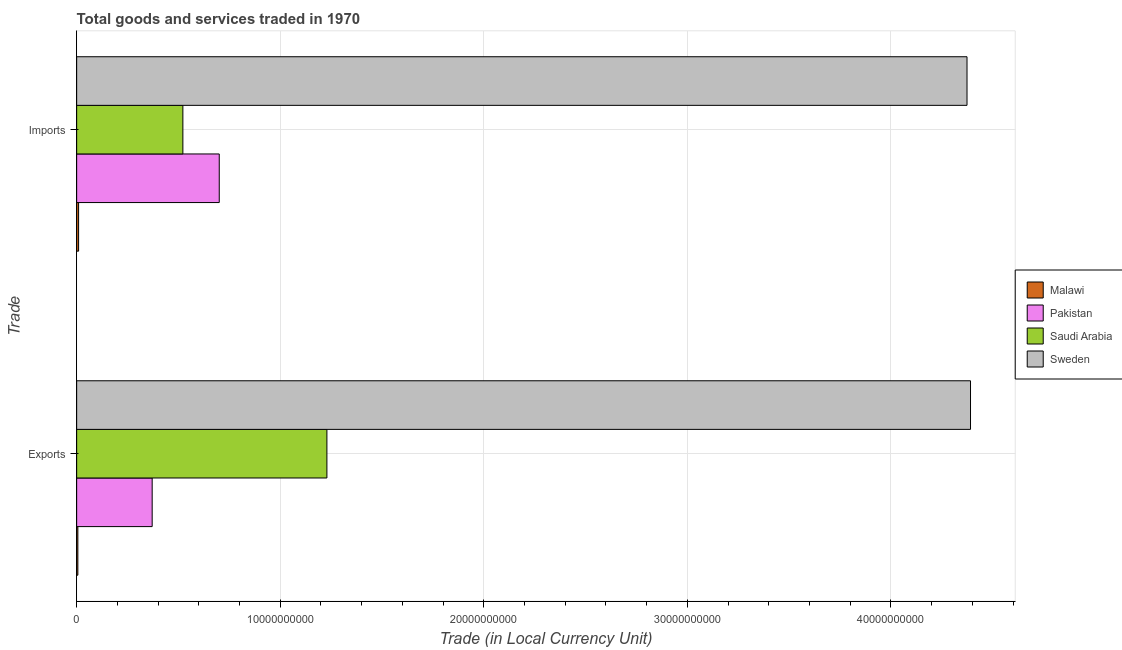How many different coloured bars are there?
Keep it short and to the point. 4. How many bars are there on the 2nd tick from the bottom?
Keep it short and to the point. 4. What is the label of the 2nd group of bars from the top?
Ensure brevity in your answer.  Exports. What is the imports of goods and services in Malawi?
Your answer should be very brief. 9.48e+07. Across all countries, what is the maximum export of goods and services?
Your answer should be compact. 4.39e+1. Across all countries, what is the minimum export of goods and services?
Your answer should be very brief. 5.87e+07. In which country was the export of goods and services maximum?
Make the answer very short. Sweden. In which country was the imports of goods and services minimum?
Your answer should be very brief. Malawi. What is the total imports of goods and services in the graph?
Provide a short and direct response. 5.61e+1. What is the difference between the export of goods and services in Pakistan and that in Sweden?
Your response must be concise. -4.02e+1. What is the difference between the imports of goods and services in Saudi Arabia and the export of goods and services in Malawi?
Provide a succinct answer. 5.16e+09. What is the average imports of goods and services per country?
Offer a very short reply. 1.40e+1. What is the difference between the imports of goods and services and export of goods and services in Pakistan?
Provide a short and direct response. 3.30e+09. In how many countries, is the export of goods and services greater than 2000000000 LCU?
Provide a succinct answer. 3. What is the ratio of the imports of goods and services in Pakistan to that in Malawi?
Offer a very short reply. 73.89. In how many countries, is the imports of goods and services greater than the average imports of goods and services taken over all countries?
Ensure brevity in your answer.  1. What does the 3rd bar from the bottom in Imports represents?
Keep it short and to the point. Saudi Arabia. How many bars are there?
Ensure brevity in your answer.  8. Are the values on the major ticks of X-axis written in scientific E-notation?
Make the answer very short. No. Does the graph contain any zero values?
Make the answer very short. No. Does the graph contain grids?
Provide a succinct answer. Yes. What is the title of the graph?
Give a very brief answer. Total goods and services traded in 1970. Does "Qatar" appear as one of the legend labels in the graph?
Your response must be concise. No. What is the label or title of the X-axis?
Your response must be concise. Trade (in Local Currency Unit). What is the label or title of the Y-axis?
Ensure brevity in your answer.  Trade. What is the Trade (in Local Currency Unit) of Malawi in Exports?
Provide a succinct answer. 5.87e+07. What is the Trade (in Local Currency Unit) in Pakistan in Exports?
Ensure brevity in your answer.  3.71e+09. What is the Trade (in Local Currency Unit) of Saudi Arabia in Exports?
Your answer should be very brief. 1.23e+1. What is the Trade (in Local Currency Unit) in Sweden in Exports?
Your answer should be compact. 4.39e+1. What is the Trade (in Local Currency Unit) in Malawi in Imports?
Your answer should be compact. 9.48e+07. What is the Trade (in Local Currency Unit) in Pakistan in Imports?
Ensure brevity in your answer.  7.00e+09. What is the Trade (in Local Currency Unit) in Saudi Arabia in Imports?
Keep it short and to the point. 5.22e+09. What is the Trade (in Local Currency Unit) of Sweden in Imports?
Make the answer very short. 4.37e+1. Across all Trade, what is the maximum Trade (in Local Currency Unit) in Malawi?
Give a very brief answer. 9.48e+07. Across all Trade, what is the maximum Trade (in Local Currency Unit) in Pakistan?
Your response must be concise. 7.00e+09. Across all Trade, what is the maximum Trade (in Local Currency Unit) in Saudi Arabia?
Give a very brief answer. 1.23e+1. Across all Trade, what is the maximum Trade (in Local Currency Unit) of Sweden?
Your response must be concise. 4.39e+1. Across all Trade, what is the minimum Trade (in Local Currency Unit) of Malawi?
Provide a succinct answer. 5.87e+07. Across all Trade, what is the minimum Trade (in Local Currency Unit) in Pakistan?
Your response must be concise. 3.71e+09. Across all Trade, what is the minimum Trade (in Local Currency Unit) in Saudi Arabia?
Your answer should be compact. 5.22e+09. Across all Trade, what is the minimum Trade (in Local Currency Unit) in Sweden?
Your answer should be very brief. 4.37e+1. What is the total Trade (in Local Currency Unit) in Malawi in the graph?
Make the answer very short. 1.54e+08. What is the total Trade (in Local Currency Unit) in Pakistan in the graph?
Provide a succinct answer. 1.07e+1. What is the total Trade (in Local Currency Unit) of Saudi Arabia in the graph?
Your response must be concise. 1.75e+1. What is the total Trade (in Local Currency Unit) in Sweden in the graph?
Make the answer very short. 8.76e+1. What is the difference between the Trade (in Local Currency Unit) of Malawi in Exports and that in Imports?
Your answer should be compact. -3.61e+07. What is the difference between the Trade (in Local Currency Unit) in Pakistan in Exports and that in Imports?
Provide a short and direct response. -3.30e+09. What is the difference between the Trade (in Local Currency Unit) in Saudi Arabia in Exports and that in Imports?
Your answer should be compact. 7.08e+09. What is the difference between the Trade (in Local Currency Unit) in Sweden in Exports and that in Imports?
Offer a terse response. 1.72e+08. What is the difference between the Trade (in Local Currency Unit) of Malawi in Exports and the Trade (in Local Currency Unit) of Pakistan in Imports?
Give a very brief answer. -6.95e+09. What is the difference between the Trade (in Local Currency Unit) of Malawi in Exports and the Trade (in Local Currency Unit) of Saudi Arabia in Imports?
Your response must be concise. -5.16e+09. What is the difference between the Trade (in Local Currency Unit) of Malawi in Exports and the Trade (in Local Currency Unit) of Sweden in Imports?
Your answer should be compact. -4.37e+1. What is the difference between the Trade (in Local Currency Unit) in Pakistan in Exports and the Trade (in Local Currency Unit) in Saudi Arabia in Imports?
Give a very brief answer. -1.51e+09. What is the difference between the Trade (in Local Currency Unit) in Pakistan in Exports and the Trade (in Local Currency Unit) in Sweden in Imports?
Your answer should be very brief. -4.00e+1. What is the difference between the Trade (in Local Currency Unit) in Saudi Arabia in Exports and the Trade (in Local Currency Unit) in Sweden in Imports?
Offer a very short reply. -3.14e+1. What is the average Trade (in Local Currency Unit) in Malawi per Trade?
Keep it short and to the point. 7.68e+07. What is the average Trade (in Local Currency Unit) of Pakistan per Trade?
Offer a terse response. 5.36e+09. What is the average Trade (in Local Currency Unit) of Saudi Arabia per Trade?
Your response must be concise. 8.76e+09. What is the average Trade (in Local Currency Unit) in Sweden per Trade?
Offer a very short reply. 4.38e+1. What is the difference between the Trade (in Local Currency Unit) of Malawi and Trade (in Local Currency Unit) of Pakistan in Exports?
Ensure brevity in your answer.  -3.65e+09. What is the difference between the Trade (in Local Currency Unit) in Malawi and Trade (in Local Currency Unit) in Saudi Arabia in Exports?
Give a very brief answer. -1.22e+1. What is the difference between the Trade (in Local Currency Unit) of Malawi and Trade (in Local Currency Unit) of Sweden in Exports?
Offer a very short reply. -4.39e+1. What is the difference between the Trade (in Local Currency Unit) of Pakistan and Trade (in Local Currency Unit) of Saudi Arabia in Exports?
Keep it short and to the point. -8.58e+09. What is the difference between the Trade (in Local Currency Unit) of Pakistan and Trade (in Local Currency Unit) of Sweden in Exports?
Your answer should be very brief. -4.02e+1. What is the difference between the Trade (in Local Currency Unit) in Saudi Arabia and Trade (in Local Currency Unit) in Sweden in Exports?
Ensure brevity in your answer.  -3.16e+1. What is the difference between the Trade (in Local Currency Unit) in Malawi and Trade (in Local Currency Unit) in Pakistan in Imports?
Keep it short and to the point. -6.91e+09. What is the difference between the Trade (in Local Currency Unit) of Malawi and Trade (in Local Currency Unit) of Saudi Arabia in Imports?
Provide a short and direct response. -5.12e+09. What is the difference between the Trade (in Local Currency Unit) in Malawi and Trade (in Local Currency Unit) in Sweden in Imports?
Your answer should be very brief. -4.36e+1. What is the difference between the Trade (in Local Currency Unit) in Pakistan and Trade (in Local Currency Unit) in Saudi Arabia in Imports?
Make the answer very short. 1.79e+09. What is the difference between the Trade (in Local Currency Unit) of Pakistan and Trade (in Local Currency Unit) of Sweden in Imports?
Provide a short and direct response. -3.67e+1. What is the difference between the Trade (in Local Currency Unit) of Saudi Arabia and Trade (in Local Currency Unit) of Sweden in Imports?
Make the answer very short. -3.85e+1. What is the ratio of the Trade (in Local Currency Unit) in Malawi in Exports to that in Imports?
Keep it short and to the point. 0.62. What is the ratio of the Trade (in Local Currency Unit) in Pakistan in Exports to that in Imports?
Your answer should be compact. 0.53. What is the ratio of the Trade (in Local Currency Unit) in Saudi Arabia in Exports to that in Imports?
Offer a terse response. 2.36. What is the ratio of the Trade (in Local Currency Unit) in Sweden in Exports to that in Imports?
Offer a very short reply. 1. What is the difference between the highest and the second highest Trade (in Local Currency Unit) in Malawi?
Give a very brief answer. 3.61e+07. What is the difference between the highest and the second highest Trade (in Local Currency Unit) of Pakistan?
Your answer should be very brief. 3.30e+09. What is the difference between the highest and the second highest Trade (in Local Currency Unit) of Saudi Arabia?
Your answer should be very brief. 7.08e+09. What is the difference between the highest and the second highest Trade (in Local Currency Unit) in Sweden?
Offer a terse response. 1.72e+08. What is the difference between the highest and the lowest Trade (in Local Currency Unit) in Malawi?
Make the answer very short. 3.61e+07. What is the difference between the highest and the lowest Trade (in Local Currency Unit) in Pakistan?
Your answer should be compact. 3.30e+09. What is the difference between the highest and the lowest Trade (in Local Currency Unit) of Saudi Arabia?
Provide a short and direct response. 7.08e+09. What is the difference between the highest and the lowest Trade (in Local Currency Unit) in Sweden?
Offer a very short reply. 1.72e+08. 